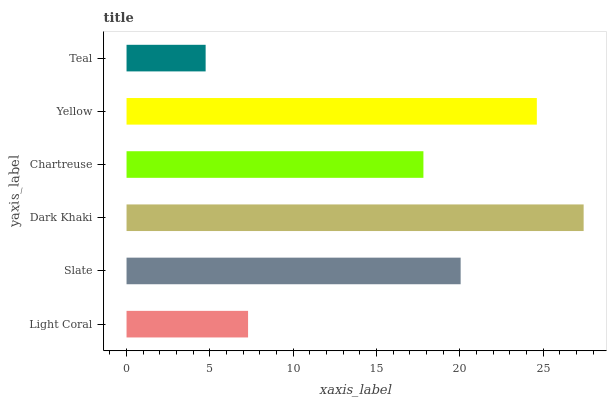Is Teal the minimum?
Answer yes or no. Yes. Is Dark Khaki the maximum?
Answer yes or no. Yes. Is Slate the minimum?
Answer yes or no. No. Is Slate the maximum?
Answer yes or no. No. Is Slate greater than Light Coral?
Answer yes or no. Yes. Is Light Coral less than Slate?
Answer yes or no. Yes. Is Light Coral greater than Slate?
Answer yes or no. No. Is Slate less than Light Coral?
Answer yes or no. No. Is Slate the high median?
Answer yes or no. Yes. Is Chartreuse the low median?
Answer yes or no. Yes. Is Teal the high median?
Answer yes or no. No. Is Yellow the low median?
Answer yes or no. No. 